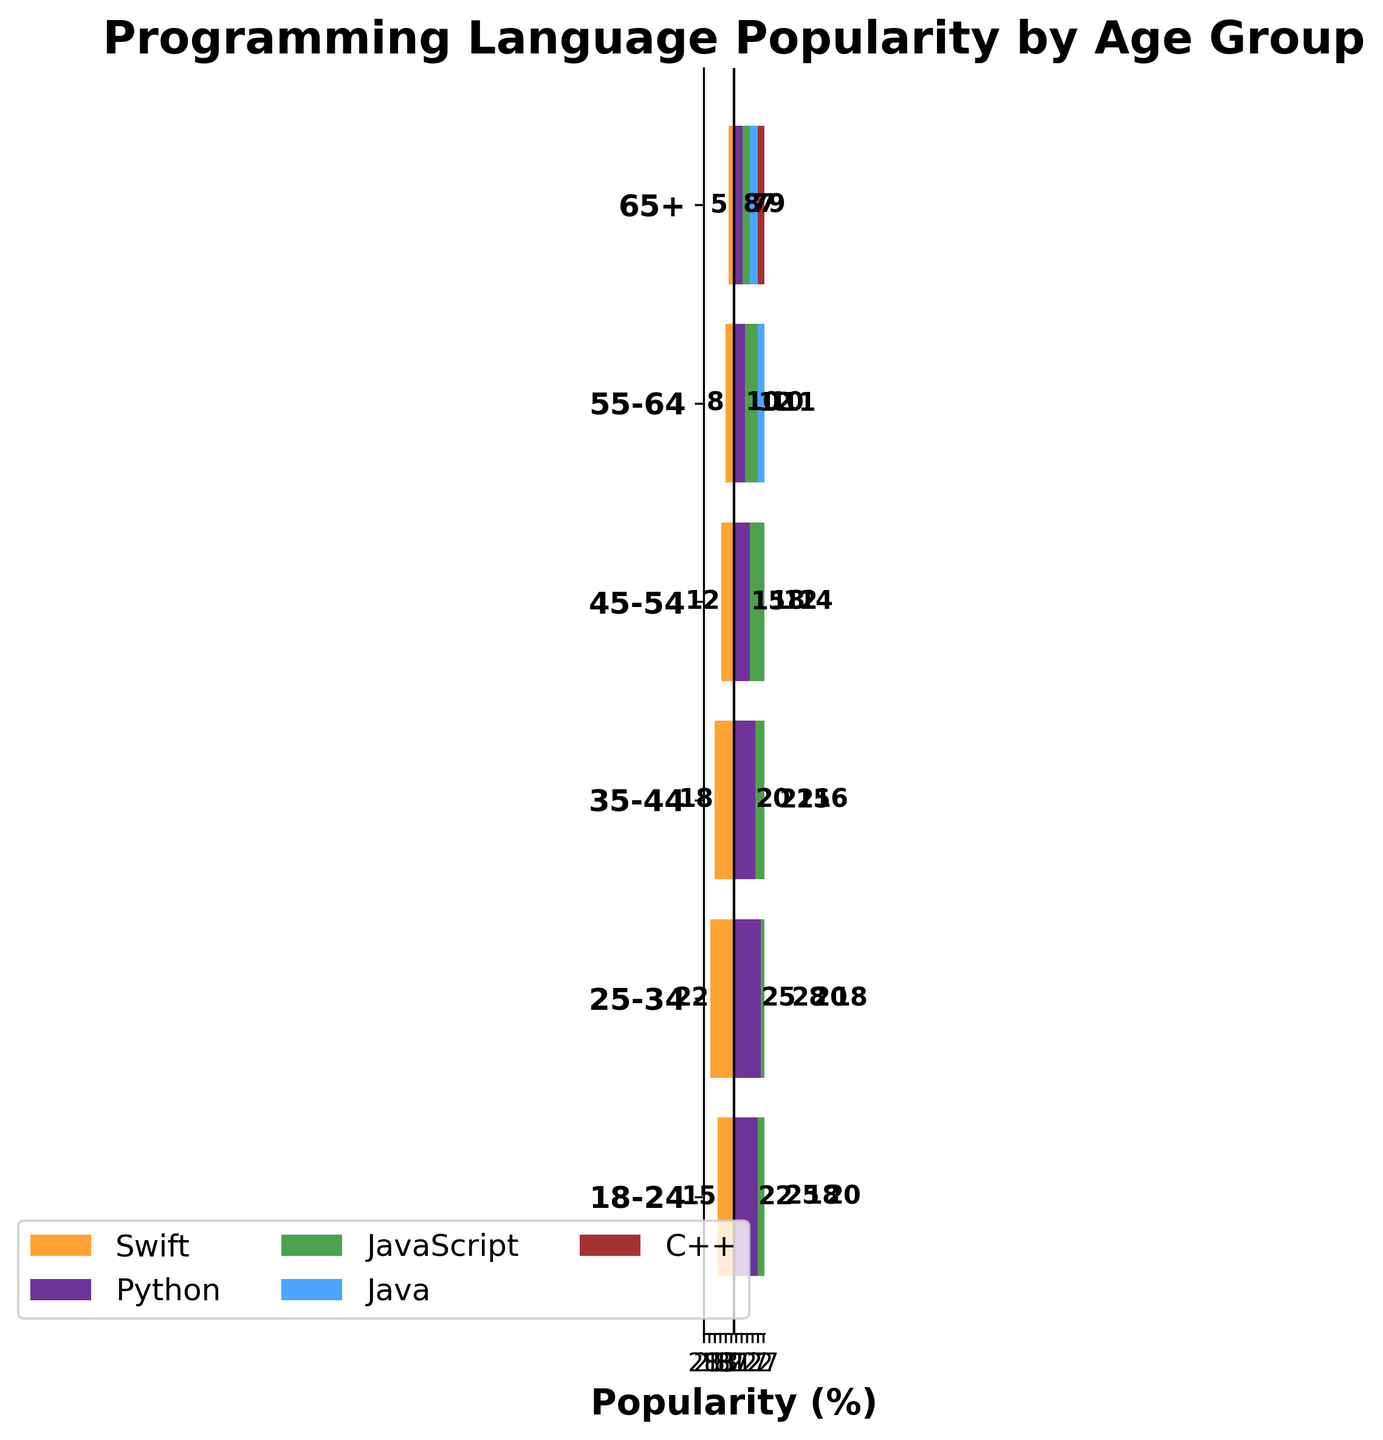What's the title of the figure? The title is located at the top of the figure and is easily identifiable.
Answer: Programming Language Popularity by Age Group Which age group has the highest popularity for JavaScript? By looking at the bars for JavaScript, the longest bar corresponds to the 25-34 age group.
Answer: 25-34 What is the difference in popularity between Python and JavaScript in the 18-24 age group? The bar for Python is at 22% and the bar for JavaScript is at 25%. The difference is 25 - 22.
Answer: 3% Which two programming languages have the closest popularity percentages in the 55-64 age group? By comparing the lengths of the bars for the 55-64 age group, Java (10%) and C++ (11%) are closest in values.
Answer: Java and C++ How much more popular is Swift among 35-44 year-olds compared to those aged 45-54? The bar for Swift is 18% for the 35-44 age group and 12% for the 45-54 age group. The difference is 18 - 12.
Answer: 6% Which programming language shows a steady decline in popularity as age increases? Looking at the bars across all age groups, Python shows a consistent decrease in popularity from younger to older age groups.
Answer: Python How many age groups have the popularity of Swift greater than or equal to 15%? By visual inspection, the age groups 18-24, 25-34, and 35-44 have Swift popularity of 15% or more.
Answer: 3 What is the combined popularity of Java and C++ in the 65+ age group? The popularity of Java is 7% and C++ is 9%. The combined popularity is 7 + 9.
Answer: 16% Which age group has the smallest total popularity across all programming languages? Summing up the percentages for each age group, the 65+ group has the smallest total (Swift: 5%, Python: 8%, JavaScript: 7%, Java: 7%, and C++: 9%).
Answer: 65+ In which age group is Python more popular than Swift by the greatest margin? By comparing the differences in percentages between Python and Swift in each age group, the 25-34 age group has the greatest margin (25% - 22% = 3%).
Answer: 25-34 